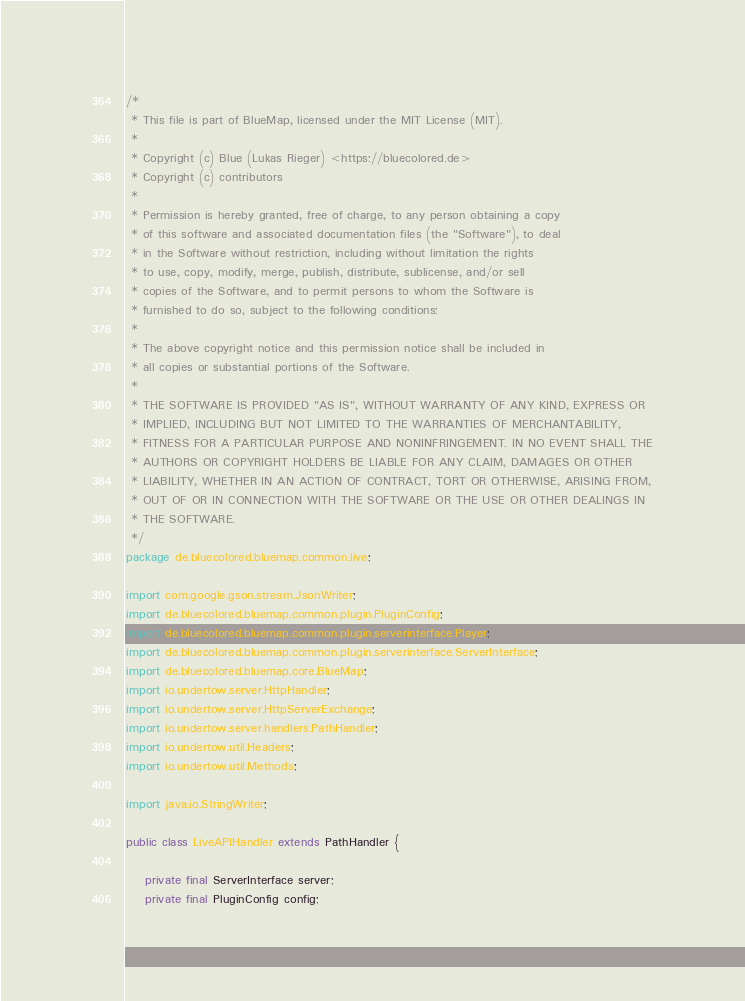Convert code to text. <code><loc_0><loc_0><loc_500><loc_500><_Java_>/*
 * This file is part of BlueMap, licensed under the MIT License (MIT).
 *
 * Copyright (c) Blue (Lukas Rieger) <https://bluecolored.de>
 * Copyright (c) contributors
 *
 * Permission is hereby granted, free of charge, to any person obtaining a copy
 * of this software and associated documentation files (the "Software"), to deal
 * in the Software without restriction, including without limitation the rights
 * to use, copy, modify, merge, publish, distribute, sublicense, and/or sell
 * copies of the Software, and to permit persons to whom the Software is
 * furnished to do so, subject to the following conditions:
 *
 * The above copyright notice and this permission notice shall be included in
 * all copies or substantial portions of the Software.
 *
 * THE SOFTWARE IS PROVIDED "AS IS", WITHOUT WARRANTY OF ANY KIND, EXPRESS OR
 * IMPLIED, INCLUDING BUT NOT LIMITED TO THE WARRANTIES OF MERCHANTABILITY,
 * FITNESS FOR A PARTICULAR PURPOSE AND NONINFRINGEMENT. IN NO EVENT SHALL THE
 * AUTHORS OR COPYRIGHT HOLDERS BE LIABLE FOR ANY CLAIM, DAMAGES OR OTHER
 * LIABILITY, WHETHER IN AN ACTION OF CONTRACT, TORT OR OTHERWISE, ARISING FROM,
 * OUT OF OR IN CONNECTION WITH THE SOFTWARE OR THE USE OR OTHER DEALINGS IN
 * THE SOFTWARE.
 */
package de.bluecolored.bluemap.common.live;

import com.google.gson.stream.JsonWriter;
import de.bluecolored.bluemap.common.plugin.PluginConfig;
import de.bluecolored.bluemap.common.plugin.serverinterface.Player;
import de.bluecolored.bluemap.common.plugin.serverinterface.ServerInterface;
import de.bluecolored.bluemap.core.BlueMap;
import io.undertow.server.HttpHandler;
import io.undertow.server.HttpServerExchange;
import io.undertow.server.handlers.PathHandler;
import io.undertow.util.Headers;
import io.undertow.util.Methods;

import java.io.StringWriter;

public class LiveAPIHandler extends PathHandler {

    private final ServerInterface server;
    private final PluginConfig config;
</code> 